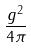Convert formula to latex. <formula><loc_0><loc_0><loc_500><loc_500>\frac { g ^ { 2 } } { 4 \pi }</formula> 